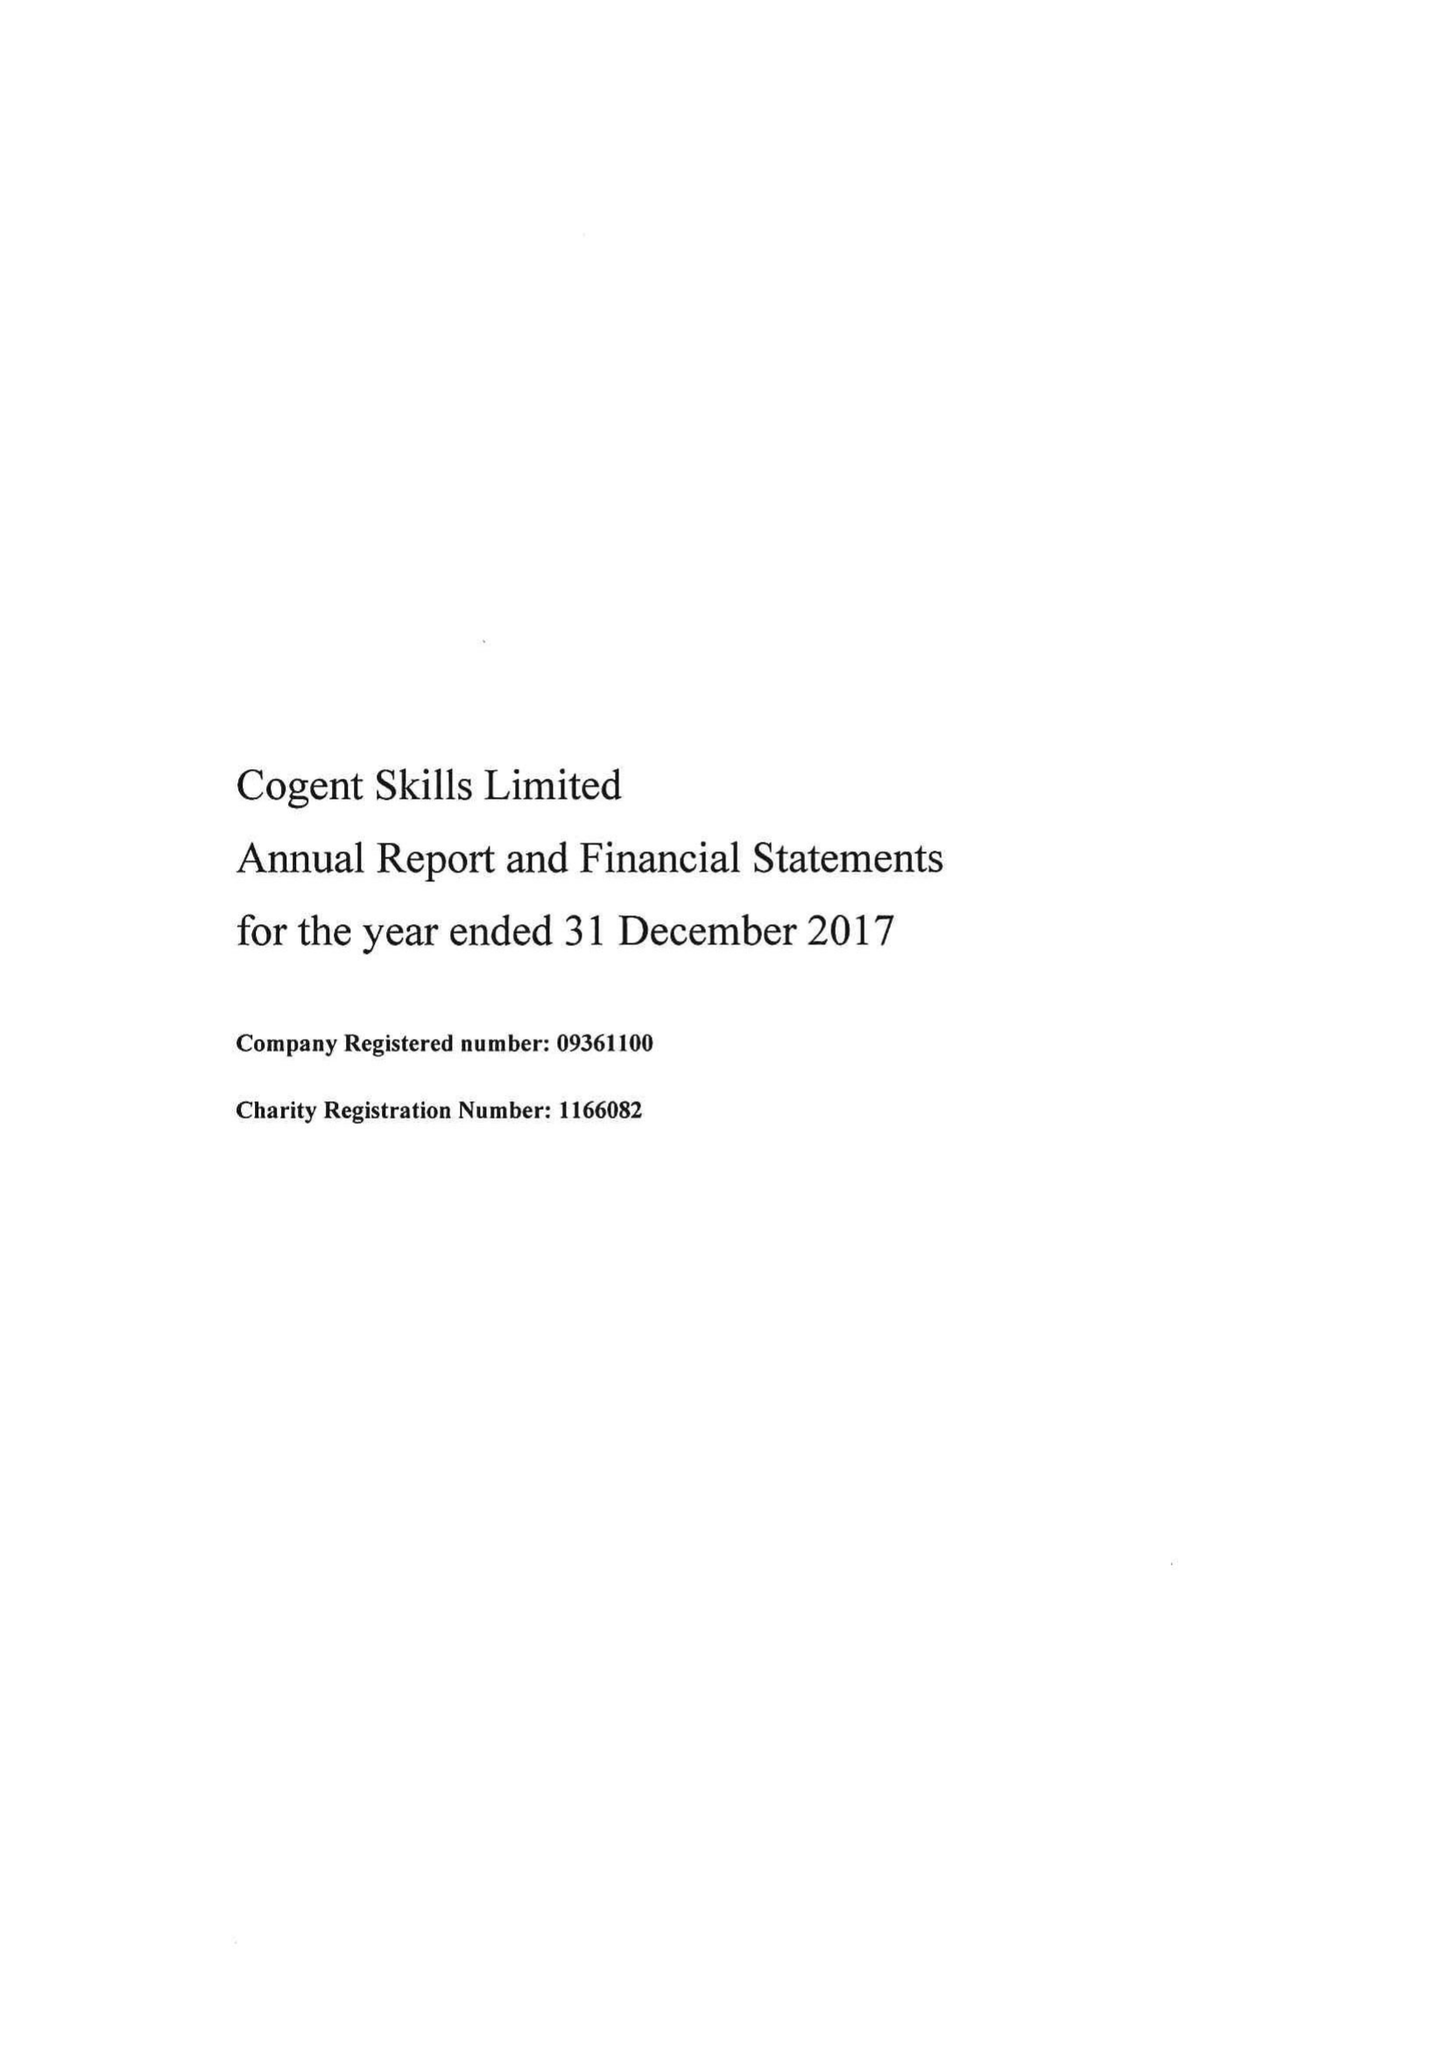What is the value for the charity_number?
Answer the question using a single word or phrase. 1166082 